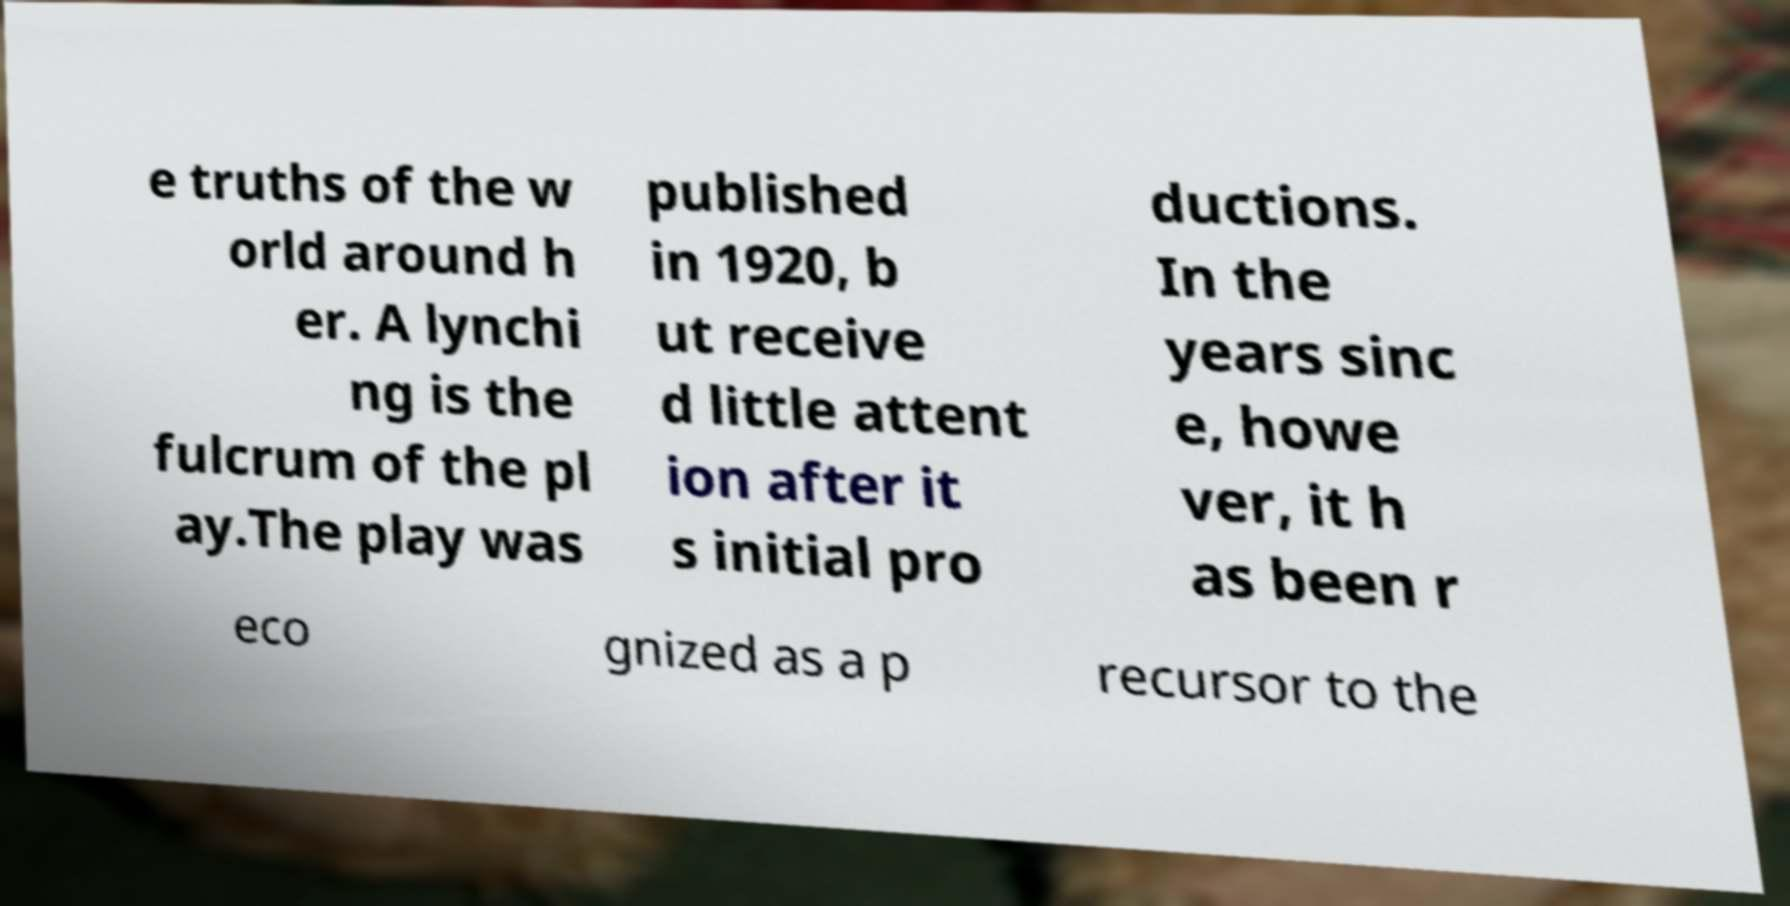I need the written content from this picture converted into text. Can you do that? e truths of the w orld around h er. A lynchi ng is the fulcrum of the pl ay.The play was published in 1920, b ut receive d little attent ion after it s initial pro ductions. In the years sinc e, howe ver, it h as been r eco gnized as a p recursor to the 